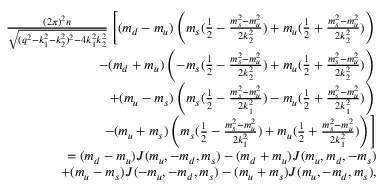<formula> <loc_0><loc_0><loc_500><loc_500>\begin{array} { r l r } & { \frac { ( 2 \pi ) ^ { 2 } n } { \sqrt { ( q ^ { 2 } - k _ { 1 } ^ { 2 } - k _ { 2 } ^ { 2 } ) ^ { 2 } - 4 k _ { 1 } ^ { 2 } k _ { 2 } ^ { 2 } } } \left [ ( m _ { d } - m _ { u } ) \left ( m _ { s } ( \frac { 1 } { 2 } - \frac { m _ { s } ^ { 2 } - m _ { u } ^ { 2 } } { 2 k _ { 2 } ^ { 2 } } ) + m _ { u } ( \frac { 1 } { 2 } + \frac { m _ { s } ^ { 2 } - m _ { u } ^ { 2 } } { 2 k _ { 2 } ^ { 2 } } ) \right ) } \\ & { - ( m _ { d } + m _ { u } ) \left ( - m _ { s } ( \frac { 1 } { 2 } - \frac { m _ { s } ^ { 2 } - m _ { u } ^ { 2 } } { 2 k _ { 2 } ^ { 2 } } ) + m _ { u } ( \frac { 1 } { 2 } + \frac { m _ { s } ^ { 2 } - m _ { u } ^ { 2 } } { 2 k _ { 2 } ^ { 2 } } ) \right ) } \\ & { + ( m _ { u } - m _ { s } ) \left ( m _ { s } ( \frac { 1 } { 2 } - \frac { m _ { s } ^ { 2 } - m _ { u } ^ { 2 } } { 2 k _ { 1 } ^ { 2 } } ) - m _ { u } ( \frac { 1 } { 2 } + \frac { m _ { s } ^ { 2 } - m _ { u } ^ { 2 } } { 2 k _ { 1 } ^ { 2 } } ) \right ) } \\ & { - ( m _ { u } + m _ { s } ) \left ( m _ { s } ( \frac { 1 } { 2 } - \frac { m _ { s } ^ { 2 } - m _ { u } ^ { 2 } } { 2 k _ { 1 } ^ { 2 } } ) + m _ { u } ( \frac { 1 } { 2 } + \frac { m _ { s } ^ { 2 } - m _ { u } ^ { 2 } } { 2 k _ { 1 } ^ { 2 } } ) \right ) \right ] } \\ & { = ( m _ { d } - m _ { u } ) J ( m _ { u } , - m _ { d } , m _ { s } ) - ( m _ { d } + m _ { u } ) J ( m _ { u } , m _ { d } , - m _ { s } ) } \\ & { + ( m _ { u } - m _ { s } ) J ( - m _ { u } , - m _ { d } , m _ { s } ) - ( m _ { u } + m _ { s } ) J ( m _ { u } , - m _ { d } , m _ { s } ) , } \end{array}</formula> 